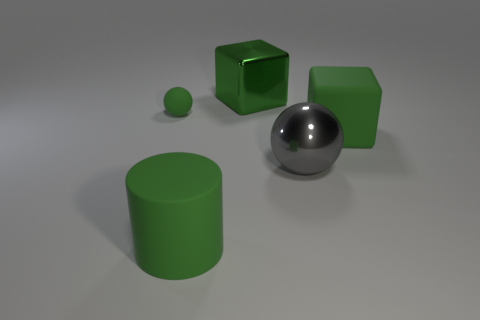What textures can be observed on the different objects in the image? The green objects display a matte texture, creating a soft appearance without significant shine or reflection. The solitary sphere in the foreground has a reflective, shiny texture, quite like polished metal, which mirrors its surroundings. 